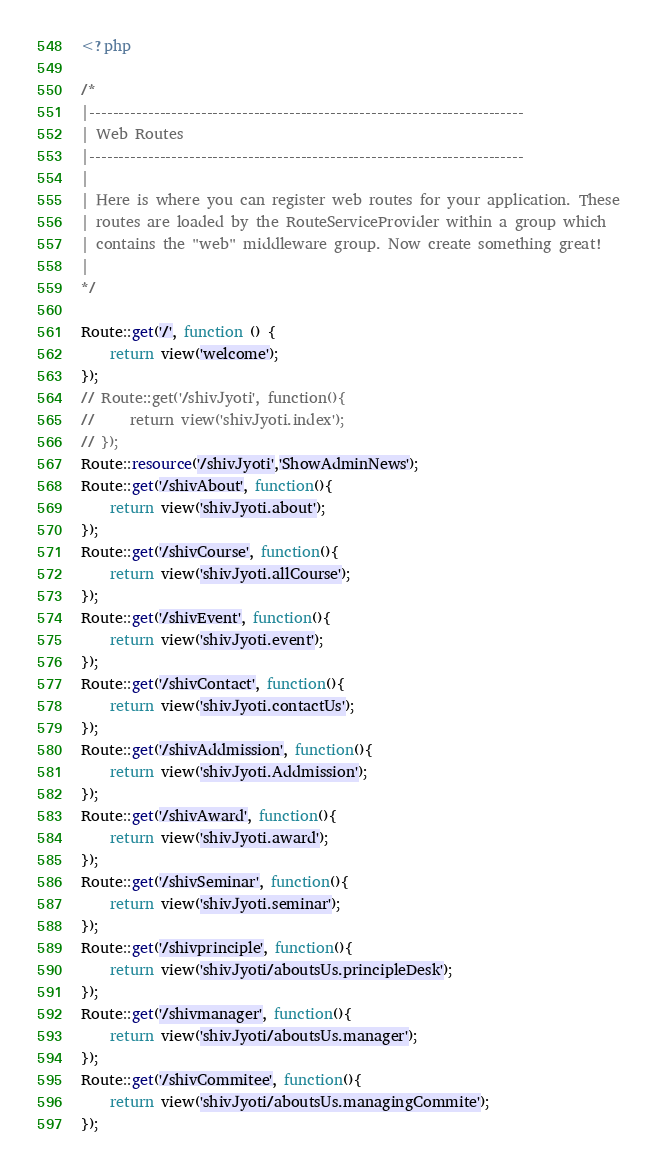<code> <loc_0><loc_0><loc_500><loc_500><_PHP_><?php

/*
|--------------------------------------------------------------------------
| Web Routes
|--------------------------------------------------------------------------
|
| Here is where you can register web routes for your application. These
| routes are loaded by the RouteServiceProvider within a group which
| contains the "web" middleware group. Now create something great!
|
*/

Route::get('/', function () {
    return view('welcome');
});
// Route::get('/shivJyoti', function(){
//     return view('shivJyoti.index');
// });
Route::resource('/shivJyoti','ShowAdminNews');
Route::get('/shivAbout', function(){
    return view('shivJyoti.about');
});
Route::get('/shivCourse', function(){
    return view('shivJyoti.allCourse');
});
Route::get('/shivEvent', function(){
    return view('shivJyoti.event');
});
Route::get('/shivContact', function(){
    return view('shivJyoti.contactUs');
});
Route::get('/shivAddmission', function(){
    return view('shivJyoti.Addmission');
});
Route::get('/shivAward', function(){
    return view('shivJyoti.award');
});
Route::get('/shivSeminar', function(){
    return view('shivJyoti.seminar');
});
Route::get('/shivprinciple', function(){
    return view('shivJyoti/aboutsUs.principleDesk');
});
Route::get('/shivmanager', function(){
    return view('shivJyoti/aboutsUs.manager');
});
Route::get('/shivCommitee', function(){
    return view('shivJyoti/aboutsUs.managingCommite');
});</code> 